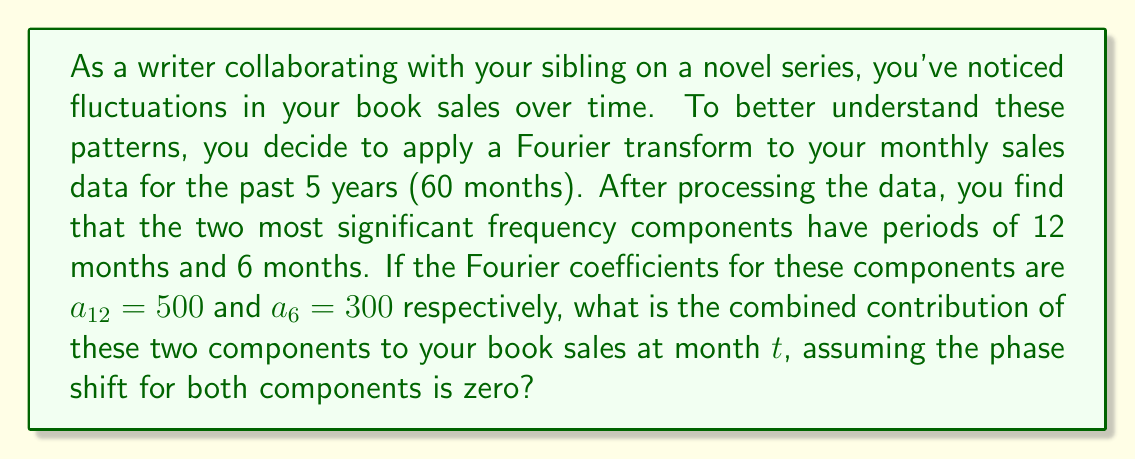Teach me how to tackle this problem. To solve this problem, we'll use the Fourier series representation of the sales data, focusing on the two most significant components. The general form of a Fourier series term is:

$$a_n \cos\left(\frac{2\pi n}{T}t + \phi_n\right)$$

Where:
- $a_n$ is the amplitude (Fourier coefficient)
- $n$ is the harmonic number
- $T$ is the fundamental period (in this case, 12 months)
- $t$ is the time (in months)
- $\phi_n$ is the phase shift (given as zero in this problem)

For the 12-month period component:
$$a_{12} \cos\left(\frac{2\pi}{12}t\right) = 500 \cos\left(\frac{\pi}{6}t\right)$$

For the 6-month period component:
$$a_6 \cos\left(\frac{2\pi}{6}t\right) = 300 \cos\left(\frac{\pi}{3}t\right)$$

The combined contribution is the sum of these two components:

$$500 \cos\left(\frac{\pi}{6}t\right) + 300 \cos\left(\frac{\pi}{3}t\right)$$

This expression represents the fluctuation in book sales due to these two periodic components at any given month $t$.
Answer: The combined contribution of the two most significant periodic components to the book sales at month $t$ is:

$$500 \cos\left(\frac{\pi}{6}t\right) + 300 \cos\left(\frac{\pi}{3}t\right)$$ 